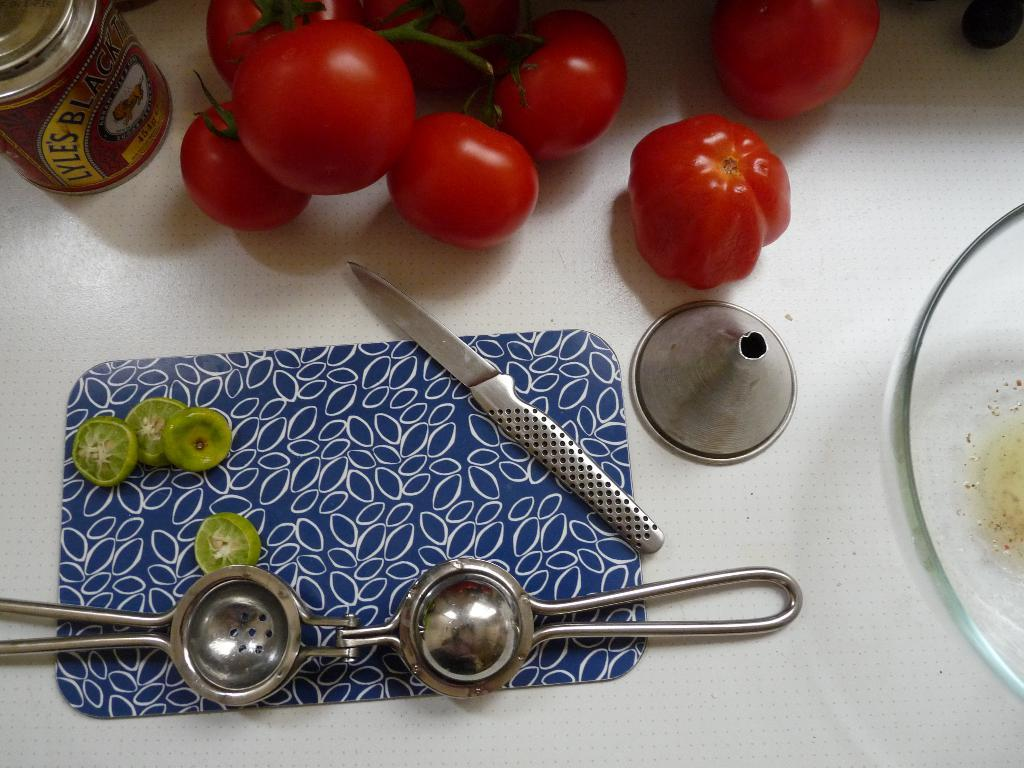What kitchen appliance is located at the bottom of the image? There is a juice extractor at the bottom of the image. What type of utensil is in the middle of the image? There is a stainless steel knife in the middle of the image. What type of food is at the top of the image? There are tomatoes at the top of the image. What type of learning can be observed in the image? There is no learning activity present in the image; it features a juice extractor, a stainless steel knife, and tomatoes. Can you describe the cloud in the image? There is no cloud present in the image. 